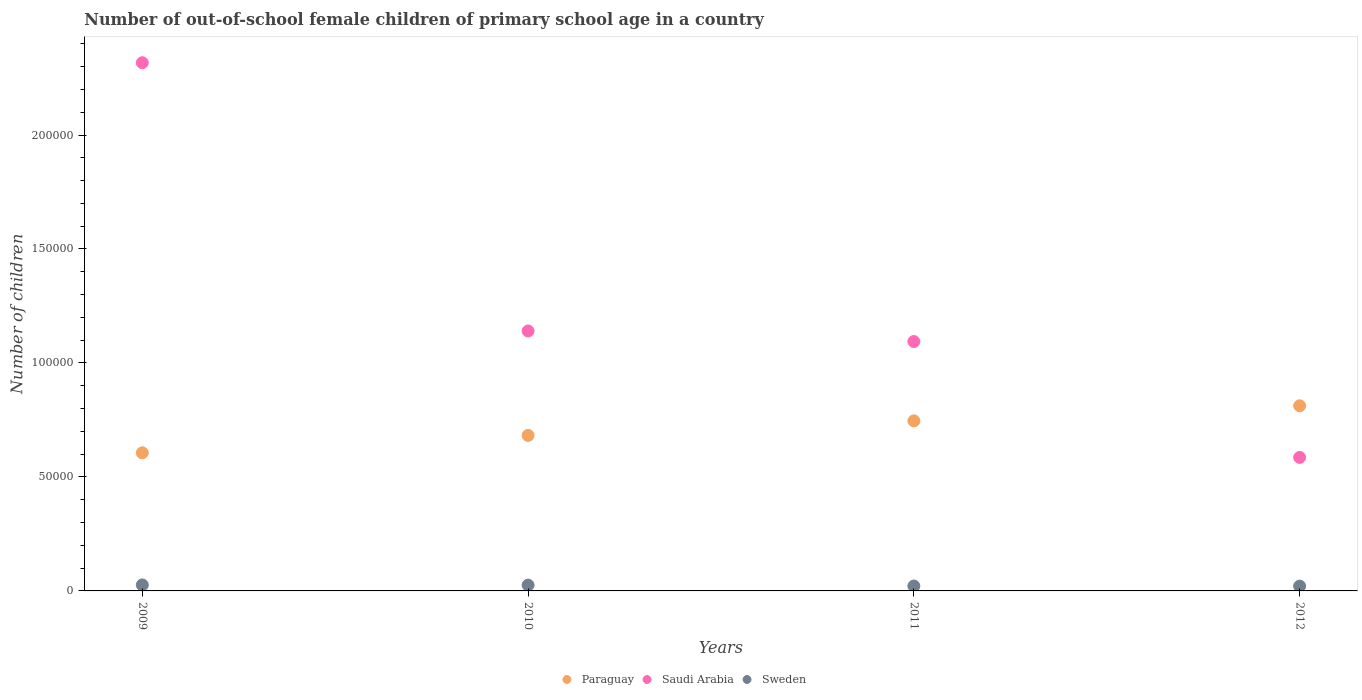Is the number of dotlines equal to the number of legend labels?
Offer a terse response. Yes. What is the number of out-of-school female children in Sweden in 2012?
Offer a terse response. 2109. Across all years, what is the maximum number of out-of-school female children in Paraguay?
Your answer should be very brief. 8.12e+04. Across all years, what is the minimum number of out-of-school female children in Paraguay?
Ensure brevity in your answer.  6.06e+04. What is the total number of out-of-school female children in Paraguay in the graph?
Your answer should be very brief. 2.85e+05. What is the difference between the number of out-of-school female children in Sweden in 2009 and that in 2012?
Make the answer very short. 519. What is the difference between the number of out-of-school female children in Sweden in 2011 and the number of out-of-school female children in Paraguay in 2009?
Your response must be concise. -5.84e+04. What is the average number of out-of-school female children in Saudi Arabia per year?
Offer a terse response. 1.28e+05. In the year 2011, what is the difference between the number of out-of-school female children in Paraguay and number of out-of-school female children in Saudi Arabia?
Offer a terse response. -3.48e+04. What is the ratio of the number of out-of-school female children in Saudi Arabia in 2009 to that in 2010?
Keep it short and to the point. 2.03. Is the difference between the number of out-of-school female children in Paraguay in 2010 and 2011 greater than the difference between the number of out-of-school female children in Saudi Arabia in 2010 and 2011?
Your answer should be very brief. No. What is the difference between the highest and the second highest number of out-of-school female children in Saudi Arabia?
Make the answer very short. 1.18e+05. What is the difference between the highest and the lowest number of out-of-school female children in Saudi Arabia?
Offer a terse response. 1.73e+05. In how many years, is the number of out-of-school female children in Saudi Arabia greater than the average number of out-of-school female children in Saudi Arabia taken over all years?
Give a very brief answer. 1. Does the number of out-of-school female children in Saudi Arabia monotonically increase over the years?
Give a very brief answer. No. Is the number of out-of-school female children in Paraguay strictly less than the number of out-of-school female children in Sweden over the years?
Your answer should be very brief. No. How many dotlines are there?
Your answer should be compact. 3. How many years are there in the graph?
Give a very brief answer. 4. Does the graph contain any zero values?
Offer a very short reply. No. What is the title of the graph?
Your answer should be compact. Number of out-of-school female children of primary school age in a country. What is the label or title of the X-axis?
Offer a terse response. Years. What is the label or title of the Y-axis?
Your answer should be very brief. Number of children. What is the Number of children in Paraguay in 2009?
Keep it short and to the point. 6.06e+04. What is the Number of children of Saudi Arabia in 2009?
Offer a terse response. 2.32e+05. What is the Number of children in Sweden in 2009?
Your answer should be very brief. 2628. What is the Number of children in Paraguay in 2010?
Offer a very short reply. 6.82e+04. What is the Number of children of Saudi Arabia in 2010?
Your response must be concise. 1.14e+05. What is the Number of children in Sweden in 2010?
Keep it short and to the point. 2546. What is the Number of children in Paraguay in 2011?
Offer a very short reply. 7.46e+04. What is the Number of children of Saudi Arabia in 2011?
Your answer should be compact. 1.09e+05. What is the Number of children in Sweden in 2011?
Keep it short and to the point. 2155. What is the Number of children in Paraguay in 2012?
Provide a succinct answer. 8.12e+04. What is the Number of children in Saudi Arabia in 2012?
Provide a short and direct response. 5.86e+04. What is the Number of children in Sweden in 2012?
Make the answer very short. 2109. Across all years, what is the maximum Number of children in Paraguay?
Offer a very short reply. 8.12e+04. Across all years, what is the maximum Number of children of Saudi Arabia?
Make the answer very short. 2.32e+05. Across all years, what is the maximum Number of children of Sweden?
Your response must be concise. 2628. Across all years, what is the minimum Number of children of Paraguay?
Provide a succinct answer. 6.06e+04. Across all years, what is the minimum Number of children of Saudi Arabia?
Offer a terse response. 5.86e+04. Across all years, what is the minimum Number of children of Sweden?
Provide a short and direct response. 2109. What is the total Number of children of Paraguay in the graph?
Your answer should be very brief. 2.85e+05. What is the total Number of children of Saudi Arabia in the graph?
Offer a very short reply. 5.14e+05. What is the total Number of children in Sweden in the graph?
Make the answer very short. 9438. What is the difference between the Number of children of Paraguay in 2009 and that in 2010?
Give a very brief answer. -7614. What is the difference between the Number of children of Saudi Arabia in 2009 and that in 2010?
Make the answer very short. 1.18e+05. What is the difference between the Number of children in Paraguay in 2009 and that in 2011?
Give a very brief answer. -1.40e+04. What is the difference between the Number of children of Saudi Arabia in 2009 and that in 2011?
Make the answer very short. 1.22e+05. What is the difference between the Number of children in Sweden in 2009 and that in 2011?
Give a very brief answer. 473. What is the difference between the Number of children of Paraguay in 2009 and that in 2012?
Keep it short and to the point. -2.06e+04. What is the difference between the Number of children of Saudi Arabia in 2009 and that in 2012?
Provide a succinct answer. 1.73e+05. What is the difference between the Number of children in Sweden in 2009 and that in 2012?
Make the answer very short. 519. What is the difference between the Number of children of Paraguay in 2010 and that in 2011?
Make the answer very short. -6406. What is the difference between the Number of children in Saudi Arabia in 2010 and that in 2011?
Offer a very short reply. 4627. What is the difference between the Number of children in Sweden in 2010 and that in 2011?
Keep it short and to the point. 391. What is the difference between the Number of children in Paraguay in 2010 and that in 2012?
Your answer should be compact. -1.30e+04. What is the difference between the Number of children in Saudi Arabia in 2010 and that in 2012?
Provide a short and direct response. 5.54e+04. What is the difference between the Number of children in Sweden in 2010 and that in 2012?
Keep it short and to the point. 437. What is the difference between the Number of children in Paraguay in 2011 and that in 2012?
Provide a short and direct response. -6595. What is the difference between the Number of children in Saudi Arabia in 2011 and that in 2012?
Offer a very short reply. 5.08e+04. What is the difference between the Number of children of Sweden in 2011 and that in 2012?
Your answer should be compact. 46. What is the difference between the Number of children of Paraguay in 2009 and the Number of children of Saudi Arabia in 2010?
Provide a succinct answer. -5.34e+04. What is the difference between the Number of children in Paraguay in 2009 and the Number of children in Sweden in 2010?
Keep it short and to the point. 5.80e+04. What is the difference between the Number of children in Saudi Arabia in 2009 and the Number of children in Sweden in 2010?
Your response must be concise. 2.29e+05. What is the difference between the Number of children in Paraguay in 2009 and the Number of children in Saudi Arabia in 2011?
Keep it short and to the point. -4.88e+04. What is the difference between the Number of children in Paraguay in 2009 and the Number of children in Sweden in 2011?
Your answer should be compact. 5.84e+04. What is the difference between the Number of children in Saudi Arabia in 2009 and the Number of children in Sweden in 2011?
Give a very brief answer. 2.30e+05. What is the difference between the Number of children in Paraguay in 2009 and the Number of children in Saudi Arabia in 2012?
Offer a very short reply. 2009. What is the difference between the Number of children of Paraguay in 2009 and the Number of children of Sweden in 2012?
Your response must be concise. 5.85e+04. What is the difference between the Number of children in Saudi Arabia in 2009 and the Number of children in Sweden in 2012?
Provide a short and direct response. 2.30e+05. What is the difference between the Number of children in Paraguay in 2010 and the Number of children in Saudi Arabia in 2011?
Your response must be concise. -4.12e+04. What is the difference between the Number of children in Paraguay in 2010 and the Number of children in Sweden in 2011?
Offer a very short reply. 6.60e+04. What is the difference between the Number of children of Saudi Arabia in 2010 and the Number of children of Sweden in 2011?
Keep it short and to the point. 1.12e+05. What is the difference between the Number of children in Paraguay in 2010 and the Number of children in Saudi Arabia in 2012?
Provide a succinct answer. 9623. What is the difference between the Number of children in Paraguay in 2010 and the Number of children in Sweden in 2012?
Offer a very short reply. 6.61e+04. What is the difference between the Number of children in Saudi Arabia in 2010 and the Number of children in Sweden in 2012?
Provide a succinct answer. 1.12e+05. What is the difference between the Number of children of Paraguay in 2011 and the Number of children of Saudi Arabia in 2012?
Offer a very short reply. 1.60e+04. What is the difference between the Number of children of Paraguay in 2011 and the Number of children of Sweden in 2012?
Offer a very short reply. 7.25e+04. What is the difference between the Number of children of Saudi Arabia in 2011 and the Number of children of Sweden in 2012?
Offer a terse response. 1.07e+05. What is the average Number of children of Paraguay per year?
Provide a short and direct response. 7.12e+04. What is the average Number of children in Saudi Arabia per year?
Your answer should be compact. 1.28e+05. What is the average Number of children of Sweden per year?
Make the answer very short. 2359.5. In the year 2009, what is the difference between the Number of children of Paraguay and Number of children of Saudi Arabia?
Offer a terse response. -1.71e+05. In the year 2009, what is the difference between the Number of children in Paraguay and Number of children in Sweden?
Provide a succinct answer. 5.80e+04. In the year 2009, what is the difference between the Number of children of Saudi Arabia and Number of children of Sweden?
Provide a succinct answer. 2.29e+05. In the year 2010, what is the difference between the Number of children in Paraguay and Number of children in Saudi Arabia?
Provide a succinct answer. -4.58e+04. In the year 2010, what is the difference between the Number of children of Paraguay and Number of children of Sweden?
Give a very brief answer. 6.57e+04. In the year 2010, what is the difference between the Number of children in Saudi Arabia and Number of children in Sweden?
Ensure brevity in your answer.  1.11e+05. In the year 2011, what is the difference between the Number of children of Paraguay and Number of children of Saudi Arabia?
Provide a short and direct response. -3.48e+04. In the year 2011, what is the difference between the Number of children in Paraguay and Number of children in Sweden?
Your response must be concise. 7.25e+04. In the year 2011, what is the difference between the Number of children in Saudi Arabia and Number of children in Sweden?
Ensure brevity in your answer.  1.07e+05. In the year 2012, what is the difference between the Number of children in Paraguay and Number of children in Saudi Arabia?
Your answer should be compact. 2.26e+04. In the year 2012, what is the difference between the Number of children of Paraguay and Number of children of Sweden?
Give a very brief answer. 7.91e+04. In the year 2012, what is the difference between the Number of children of Saudi Arabia and Number of children of Sweden?
Offer a very short reply. 5.65e+04. What is the ratio of the Number of children in Paraguay in 2009 to that in 2010?
Your answer should be compact. 0.89. What is the ratio of the Number of children of Saudi Arabia in 2009 to that in 2010?
Provide a succinct answer. 2.03. What is the ratio of the Number of children in Sweden in 2009 to that in 2010?
Offer a very short reply. 1.03. What is the ratio of the Number of children of Paraguay in 2009 to that in 2011?
Give a very brief answer. 0.81. What is the ratio of the Number of children in Saudi Arabia in 2009 to that in 2011?
Offer a terse response. 2.12. What is the ratio of the Number of children in Sweden in 2009 to that in 2011?
Give a very brief answer. 1.22. What is the ratio of the Number of children in Paraguay in 2009 to that in 2012?
Provide a succinct answer. 0.75. What is the ratio of the Number of children of Saudi Arabia in 2009 to that in 2012?
Give a very brief answer. 3.96. What is the ratio of the Number of children in Sweden in 2009 to that in 2012?
Provide a succinct answer. 1.25. What is the ratio of the Number of children of Paraguay in 2010 to that in 2011?
Provide a short and direct response. 0.91. What is the ratio of the Number of children in Saudi Arabia in 2010 to that in 2011?
Your answer should be very brief. 1.04. What is the ratio of the Number of children of Sweden in 2010 to that in 2011?
Offer a terse response. 1.18. What is the ratio of the Number of children in Paraguay in 2010 to that in 2012?
Offer a terse response. 0.84. What is the ratio of the Number of children in Saudi Arabia in 2010 to that in 2012?
Your response must be concise. 1.95. What is the ratio of the Number of children of Sweden in 2010 to that in 2012?
Ensure brevity in your answer.  1.21. What is the ratio of the Number of children in Paraguay in 2011 to that in 2012?
Provide a succinct answer. 0.92. What is the ratio of the Number of children in Saudi Arabia in 2011 to that in 2012?
Give a very brief answer. 1.87. What is the ratio of the Number of children in Sweden in 2011 to that in 2012?
Ensure brevity in your answer.  1.02. What is the difference between the highest and the second highest Number of children of Paraguay?
Offer a very short reply. 6595. What is the difference between the highest and the second highest Number of children in Saudi Arabia?
Ensure brevity in your answer.  1.18e+05. What is the difference between the highest and the second highest Number of children in Sweden?
Provide a succinct answer. 82. What is the difference between the highest and the lowest Number of children of Paraguay?
Offer a very short reply. 2.06e+04. What is the difference between the highest and the lowest Number of children of Saudi Arabia?
Make the answer very short. 1.73e+05. What is the difference between the highest and the lowest Number of children in Sweden?
Ensure brevity in your answer.  519. 